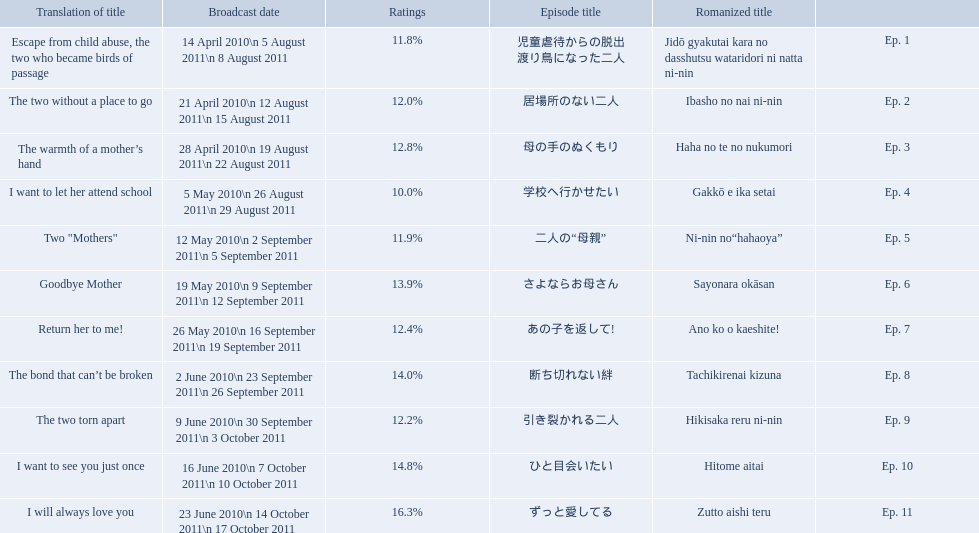How many total episodes are there? Ep. 1, Ep. 2, Ep. 3, Ep. 4, Ep. 5, Ep. 6, Ep. 7, Ep. 8, Ep. 9, Ep. 10, Ep. 11. Of those episodes, which one has the title of the bond that can't be broken? Ep. 8. What was the ratings percentage for that episode? 14.0%. What are all of the episode numbers? Ep. 1, Ep. 2, Ep. 3, Ep. 4, Ep. 5, Ep. 6, Ep. 7, Ep. 8, Ep. 9, Ep. 10, Ep. 11. And their titles? 児童虐待からの脱出 渡り鳥になった二人, 居場所のない二人, 母の手のぬくもり, 学校へ行かせたい, 二人の“母親”, さよならお母さん, あの子を返して!, 断ち切れない絆, 引き裂かれる二人, ひと目会いたい, ずっと愛してる. What about their translated names? Escape from child abuse, the two who became birds of passage, The two without a place to go, The warmth of a mother’s hand, I want to let her attend school, Two "Mothers", Goodbye Mother, Return her to me!, The bond that can’t be broken, The two torn apart, I want to see you just once, I will always love you. Which episode number's title translated to i want to let her attend school? Ep. 4. 